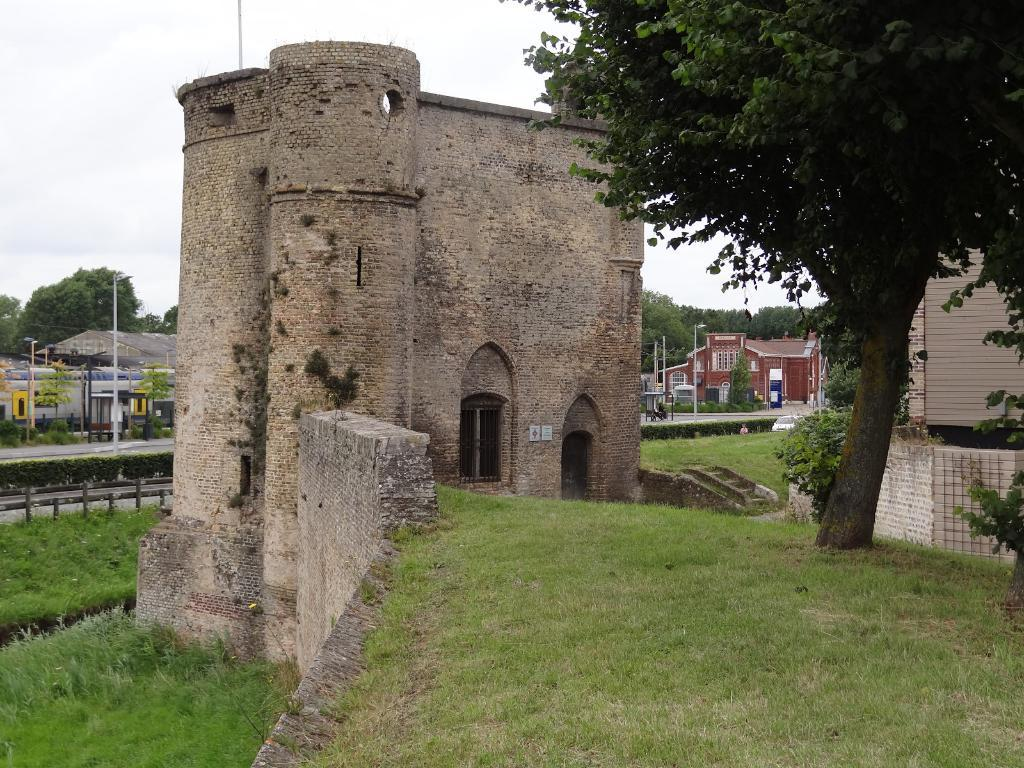What type of structure is the main subject of the image? There is a fort in the image. What other structures can be seen in the image? There are buildings in the image. What type of lighting is present in the image? Streetlights are present in the image. What type of barrier is visible in the image? There is a fence in the image. What type of vegetation is visible in the image? Grass is visible in the image. What can be seen in the background of the image? There are trees and the sky visible in the background of the image. What is the value of the alley in the image? There is no alley present in the image, so it is not possible to determine its value. 